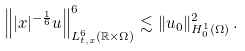<formula> <loc_0><loc_0><loc_500><loc_500>\left \| | x | ^ { - \frac { 1 } { 6 } } u \right \| ^ { 6 } _ { L _ { t , x } ^ { 6 } ( \mathbb { R } \times \Omega ) } \lesssim \| u _ { 0 } \| _ { H ^ { 1 } _ { 0 } ( \Omega ) } ^ { 2 } \, .</formula> 